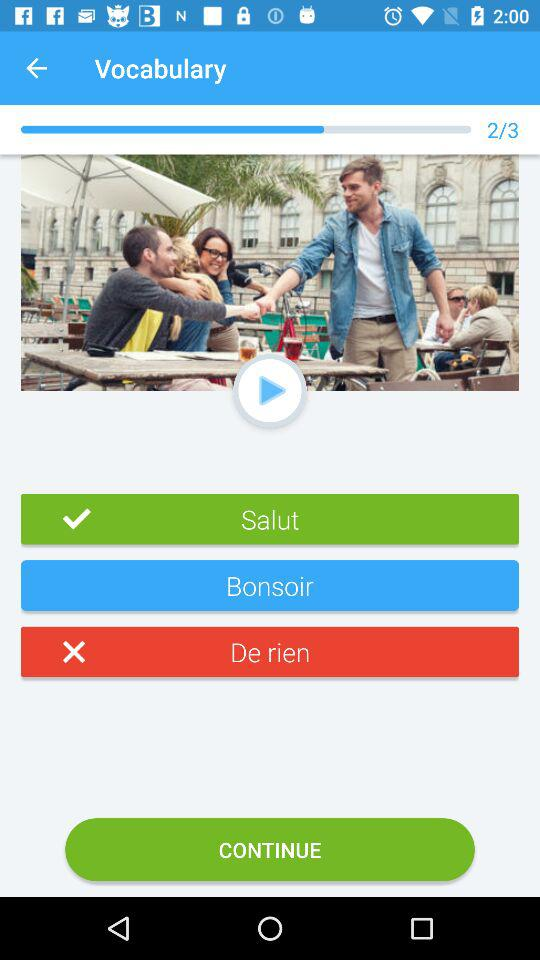How many out of three questions are answered? Out of three questions, two are answered. 